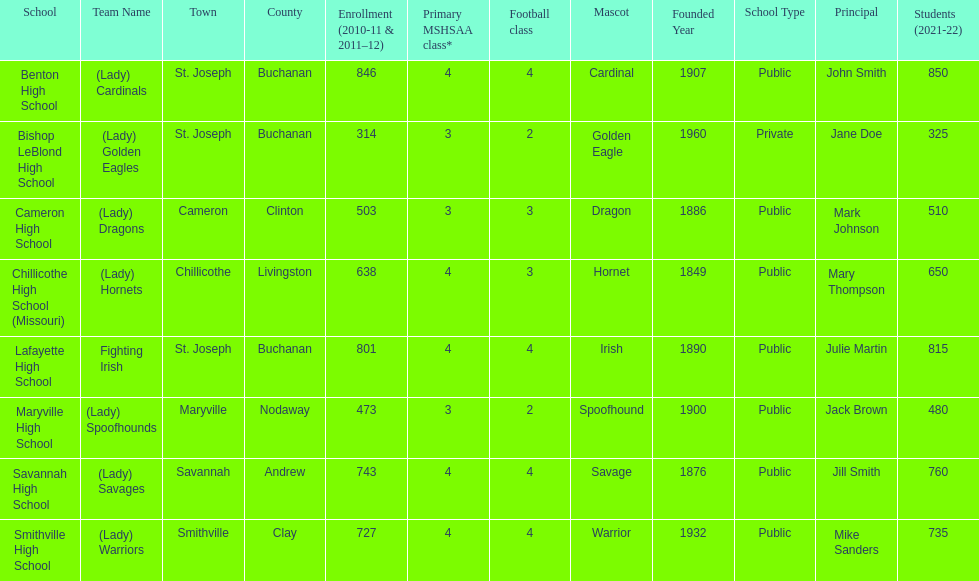Does lafayette high school or benton high school have green and grey as their colors? Lafayette High School. 